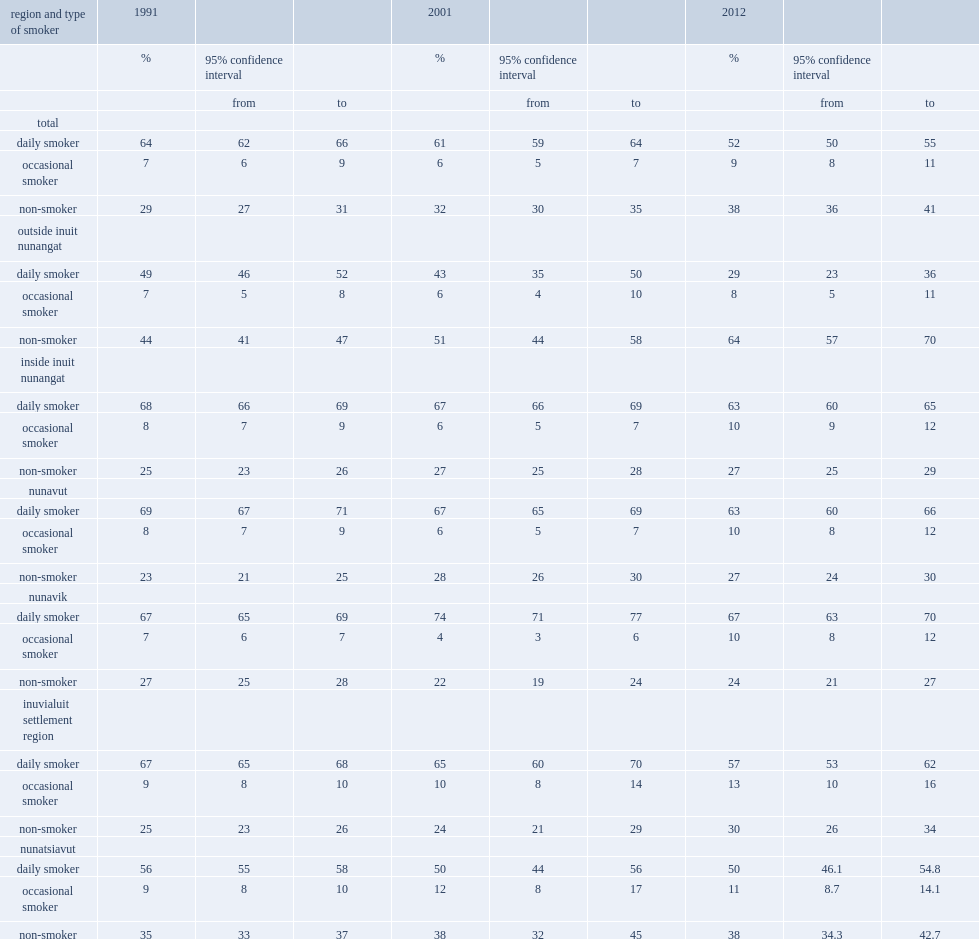What is the prevalence of daily smoking in 1991? 64.0. What is the prevalence of daily smoking in 2012? 52.0. What is the prevalence of daily smoking in 2001? 61.0. What is the prevalence of daily smoking in 2012? 52.0. In which year was occasional smoking more common among inuit, 2012 or 1991? 2012.0. In which year the prevalence of non-smoking among inuit was higher, 2012 or 1991? 2012.0. 